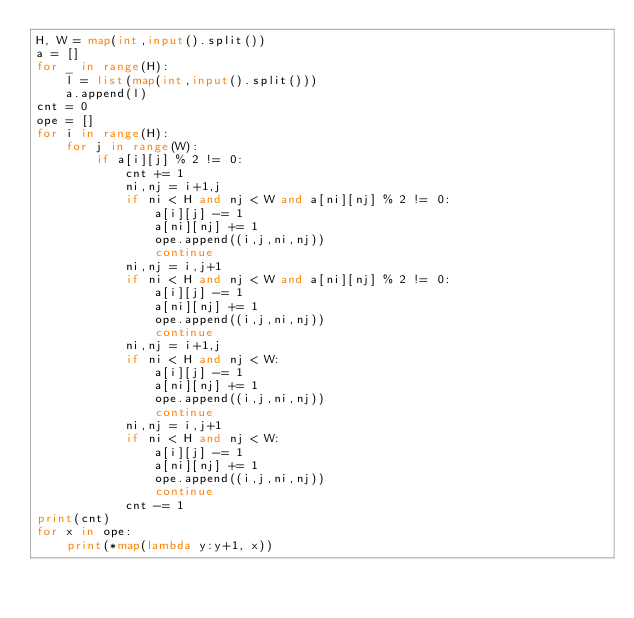<code> <loc_0><loc_0><loc_500><loc_500><_Python_>H, W = map(int,input().split())
a = []
for _ in range(H):
    l = list(map(int,input().split()))
    a.append(l)
cnt = 0
ope = []
for i in range(H):
    for j in range(W):
        if a[i][j] % 2 != 0:
            cnt += 1
            ni,nj = i+1,j
            if ni < H and nj < W and a[ni][nj] % 2 != 0:
                a[i][j] -= 1
                a[ni][nj] += 1
                ope.append((i,j,ni,nj))
                continue
            ni,nj = i,j+1
            if ni < H and nj < W and a[ni][nj] % 2 != 0:
                a[i][j] -= 1
                a[ni][nj] += 1
                ope.append((i,j,ni,nj))
                continue
            ni,nj = i+1,j
            if ni < H and nj < W:
                a[i][j] -= 1
                a[ni][nj] += 1
                ope.append((i,j,ni,nj))
                continue
            ni,nj = i,j+1
            if ni < H and nj < W:
                a[i][j] -= 1
                a[ni][nj] += 1
                ope.append((i,j,ni,nj))
                continue
            cnt -= 1
print(cnt)
for x in ope:
    print(*map(lambda y:y+1, x))</code> 